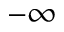Convert formula to latex. <formula><loc_0><loc_0><loc_500><loc_500>- \infty</formula> 